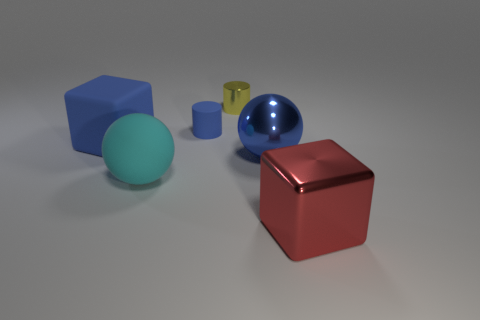What materials seem to be represented by the objects in the image? The objects in the image seem to represent a variety of materials. The large red cube has a reflective, possibly metallic surface. The blue sphere also appears shiny and reflective, suggesting a glossy, perhaps enamel-coated material. The yellow cylinder has less reflection than the red cube and blue sphere, hinting at a matte or less polished surface. Lastly, the turquoise sphere shows a smooth surface with some light reflection, which might represent a satin-finished material. 